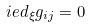<formula> <loc_0><loc_0><loc_500><loc_500>\L i e d _ { \xi } g _ { i j } = 0</formula> 